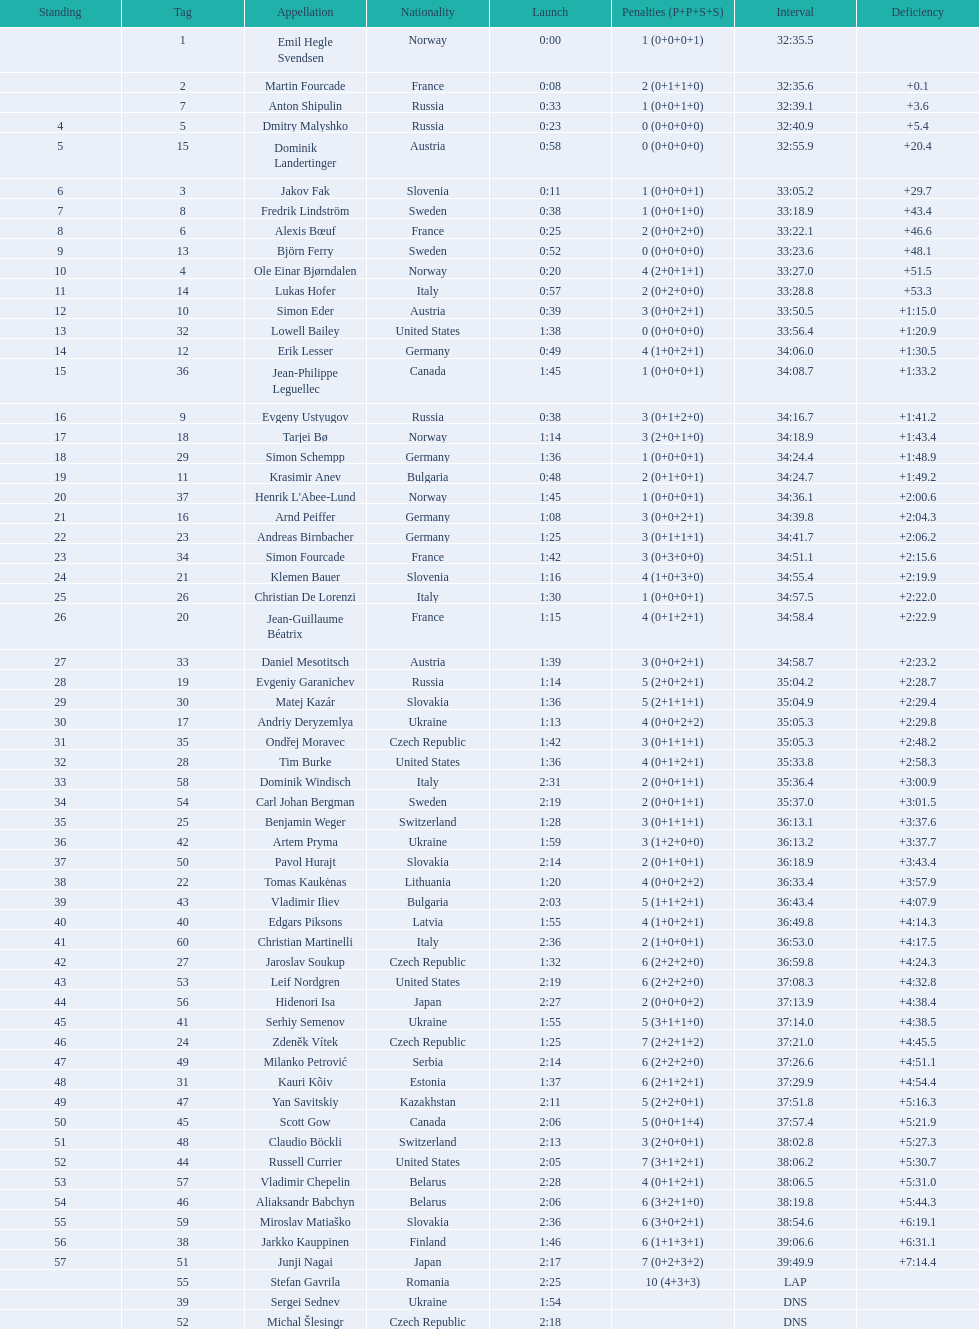Who is the top ranked runner of sweden? Fredrik Lindström. Could you help me parse every detail presented in this table? {'header': ['Standing', 'Tag', 'Appellation', 'Nationality', 'Launch', 'Penalties (P+P+S+S)', 'Interval', 'Deficiency'], 'rows': [['', '1', 'Emil Hegle Svendsen', 'Norway', '0:00', '1 (0+0+0+1)', '32:35.5', ''], ['', '2', 'Martin Fourcade', 'France', '0:08', '2 (0+1+1+0)', '32:35.6', '+0.1'], ['', '7', 'Anton Shipulin', 'Russia', '0:33', '1 (0+0+1+0)', '32:39.1', '+3.6'], ['4', '5', 'Dmitry Malyshko', 'Russia', '0:23', '0 (0+0+0+0)', '32:40.9', '+5.4'], ['5', '15', 'Dominik Landertinger', 'Austria', '0:58', '0 (0+0+0+0)', '32:55.9', '+20.4'], ['6', '3', 'Jakov Fak', 'Slovenia', '0:11', '1 (0+0+0+1)', '33:05.2', '+29.7'], ['7', '8', 'Fredrik Lindström', 'Sweden', '0:38', '1 (0+0+1+0)', '33:18.9', '+43.4'], ['8', '6', 'Alexis Bœuf', 'France', '0:25', '2 (0+0+2+0)', '33:22.1', '+46.6'], ['9', '13', 'Björn Ferry', 'Sweden', '0:52', '0 (0+0+0+0)', '33:23.6', '+48.1'], ['10', '4', 'Ole Einar Bjørndalen', 'Norway', '0:20', '4 (2+0+1+1)', '33:27.0', '+51.5'], ['11', '14', 'Lukas Hofer', 'Italy', '0:57', '2 (0+2+0+0)', '33:28.8', '+53.3'], ['12', '10', 'Simon Eder', 'Austria', '0:39', '3 (0+0+2+1)', '33:50.5', '+1:15.0'], ['13', '32', 'Lowell Bailey', 'United States', '1:38', '0 (0+0+0+0)', '33:56.4', '+1:20.9'], ['14', '12', 'Erik Lesser', 'Germany', '0:49', '4 (1+0+2+1)', '34:06.0', '+1:30.5'], ['15', '36', 'Jean-Philippe Leguellec', 'Canada', '1:45', '1 (0+0+0+1)', '34:08.7', '+1:33.2'], ['16', '9', 'Evgeny Ustyugov', 'Russia', '0:38', '3 (0+1+2+0)', '34:16.7', '+1:41.2'], ['17', '18', 'Tarjei Bø', 'Norway', '1:14', '3 (2+0+1+0)', '34:18.9', '+1:43.4'], ['18', '29', 'Simon Schempp', 'Germany', '1:36', '1 (0+0+0+1)', '34:24.4', '+1:48.9'], ['19', '11', 'Krasimir Anev', 'Bulgaria', '0:48', '2 (0+1+0+1)', '34:24.7', '+1:49.2'], ['20', '37', "Henrik L'Abee-Lund", 'Norway', '1:45', '1 (0+0+0+1)', '34:36.1', '+2:00.6'], ['21', '16', 'Arnd Peiffer', 'Germany', '1:08', '3 (0+0+2+1)', '34:39.8', '+2:04.3'], ['22', '23', 'Andreas Birnbacher', 'Germany', '1:25', '3 (0+1+1+1)', '34:41.7', '+2:06.2'], ['23', '34', 'Simon Fourcade', 'France', '1:42', '3 (0+3+0+0)', '34:51.1', '+2:15.6'], ['24', '21', 'Klemen Bauer', 'Slovenia', '1:16', '4 (1+0+3+0)', '34:55.4', '+2:19.9'], ['25', '26', 'Christian De Lorenzi', 'Italy', '1:30', '1 (0+0+0+1)', '34:57.5', '+2:22.0'], ['26', '20', 'Jean-Guillaume Béatrix', 'France', '1:15', '4 (0+1+2+1)', '34:58.4', '+2:22.9'], ['27', '33', 'Daniel Mesotitsch', 'Austria', '1:39', '3 (0+0+2+1)', '34:58.7', '+2:23.2'], ['28', '19', 'Evgeniy Garanichev', 'Russia', '1:14', '5 (2+0+2+1)', '35:04.2', '+2:28.7'], ['29', '30', 'Matej Kazár', 'Slovakia', '1:36', '5 (2+1+1+1)', '35:04.9', '+2:29.4'], ['30', '17', 'Andriy Deryzemlya', 'Ukraine', '1:13', '4 (0+0+2+2)', '35:05.3', '+2:29.8'], ['31', '35', 'Ondřej Moravec', 'Czech Republic', '1:42', '3 (0+1+1+1)', '35:05.3', '+2:48.2'], ['32', '28', 'Tim Burke', 'United States', '1:36', '4 (0+1+2+1)', '35:33.8', '+2:58.3'], ['33', '58', 'Dominik Windisch', 'Italy', '2:31', '2 (0+0+1+1)', '35:36.4', '+3:00.9'], ['34', '54', 'Carl Johan Bergman', 'Sweden', '2:19', '2 (0+0+1+1)', '35:37.0', '+3:01.5'], ['35', '25', 'Benjamin Weger', 'Switzerland', '1:28', '3 (0+1+1+1)', '36:13.1', '+3:37.6'], ['36', '42', 'Artem Pryma', 'Ukraine', '1:59', '3 (1+2+0+0)', '36:13.2', '+3:37.7'], ['37', '50', 'Pavol Hurajt', 'Slovakia', '2:14', '2 (0+1+0+1)', '36:18.9', '+3:43.4'], ['38', '22', 'Tomas Kaukėnas', 'Lithuania', '1:20', '4 (0+0+2+2)', '36:33.4', '+3:57.9'], ['39', '43', 'Vladimir Iliev', 'Bulgaria', '2:03', '5 (1+1+2+1)', '36:43.4', '+4:07.9'], ['40', '40', 'Edgars Piksons', 'Latvia', '1:55', '4 (1+0+2+1)', '36:49.8', '+4:14.3'], ['41', '60', 'Christian Martinelli', 'Italy', '2:36', '2 (1+0+0+1)', '36:53.0', '+4:17.5'], ['42', '27', 'Jaroslav Soukup', 'Czech Republic', '1:32', '6 (2+2+2+0)', '36:59.8', '+4:24.3'], ['43', '53', 'Leif Nordgren', 'United States', '2:19', '6 (2+2+2+0)', '37:08.3', '+4:32.8'], ['44', '56', 'Hidenori Isa', 'Japan', '2:27', '2 (0+0+0+2)', '37:13.9', '+4:38.4'], ['45', '41', 'Serhiy Semenov', 'Ukraine', '1:55', '5 (3+1+1+0)', '37:14.0', '+4:38.5'], ['46', '24', 'Zdeněk Vítek', 'Czech Republic', '1:25', '7 (2+2+1+2)', '37:21.0', '+4:45.5'], ['47', '49', 'Milanko Petrović', 'Serbia', '2:14', '6 (2+2+2+0)', '37:26.6', '+4:51.1'], ['48', '31', 'Kauri Kõiv', 'Estonia', '1:37', '6 (2+1+2+1)', '37:29.9', '+4:54.4'], ['49', '47', 'Yan Savitskiy', 'Kazakhstan', '2:11', '5 (2+2+0+1)', '37:51.8', '+5:16.3'], ['50', '45', 'Scott Gow', 'Canada', '2:06', '5 (0+0+1+4)', '37:57.4', '+5:21.9'], ['51', '48', 'Claudio Böckli', 'Switzerland', '2:13', '3 (2+0+0+1)', '38:02.8', '+5:27.3'], ['52', '44', 'Russell Currier', 'United States', '2:05', '7 (3+1+2+1)', '38:06.2', '+5:30.7'], ['53', '57', 'Vladimir Chepelin', 'Belarus', '2:28', '4 (0+1+2+1)', '38:06.5', '+5:31.0'], ['54', '46', 'Aliaksandr Babchyn', 'Belarus', '2:06', '6 (3+2+1+0)', '38:19.8', '+5:44.3'], ['55', '59', 'Miroslav Matiaško', 'Slovakia', '2:36', '6 (3+0+2+1)', '38:54.6', '+6:19.1'], ['56', '38', 'Jarkko Kauppinen', 'Finland', '1:46', '6 (1+1+3+1)', '39:06.6', '+6:31.1'], ['57', '51', 'Junji Nagai', 'Japan', '2:17', '7 (0+2+3+2)', '39:49.9', '+7:14.4'], ['', '55', 'Stefan Gavrila', 'Romania', '2:25', '10 (4+3+3)', 'LAP', ''], ['', '39', 'Sergei Sednev', 'Ukraine', '1:54', '', 'DNS', ''], ['', '52', 'Michal Šlesingr', 'Czech Republic', '2:18', '', 'DNS', '']]} 